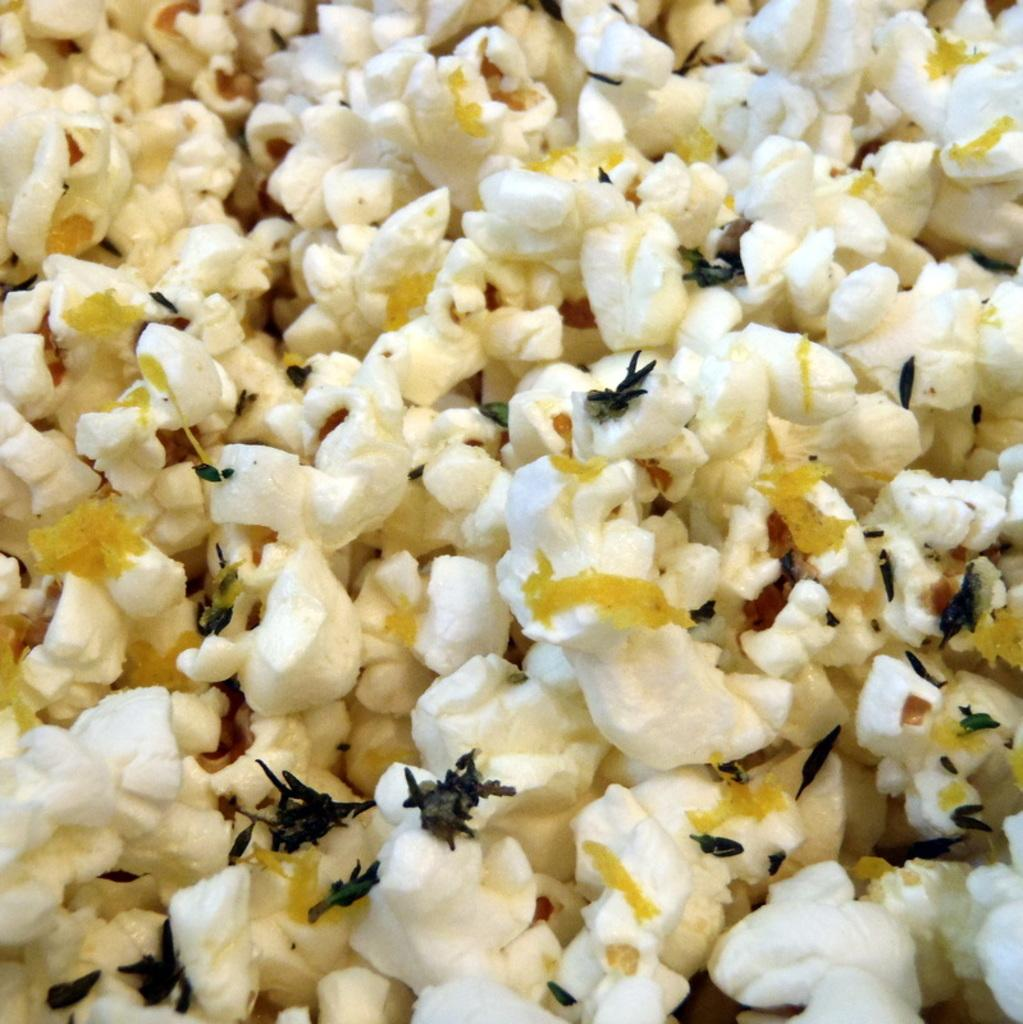What type of food is present in the image? There is popcorn in the image. What story is being told by the popcorn in the image? There is no story being told by the popcorn in the image, as popcorn is an inanimate object and cannot communicate or tell stories. 